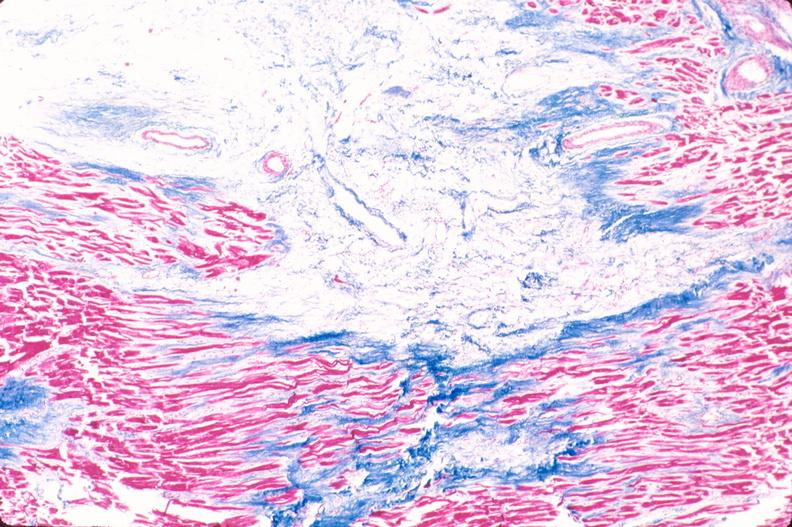does this image show heart, old myocardial infarction with fibrosis, trichrome?
Answer the question using a single word or phrase. Yes 